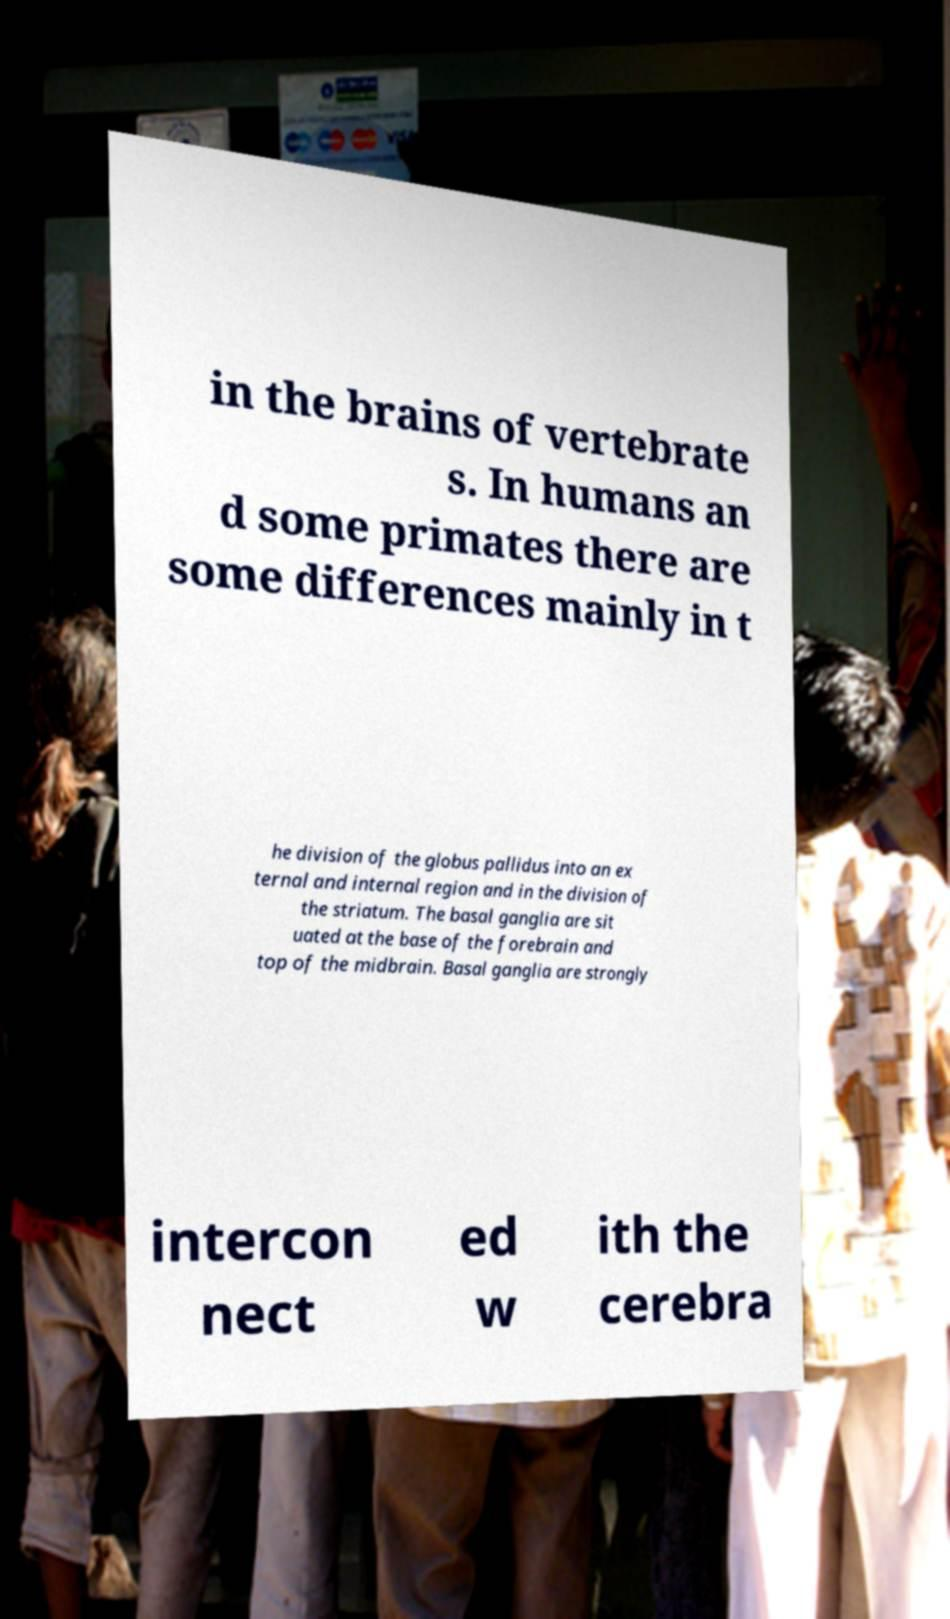What messages or text are displayed in this image? I need them in a readable, typed format. in the brains of vertebrate s. In humans an d some primates there are some differences mainly in t he division of the globus pallidus into an ex ternal and internal region and in the division of the striatum. The basal ganglia are sit uated at the base of the forebrain and top of the midbrain. Basal ganglia are strongly intercon nect ed w ith the cerebra 